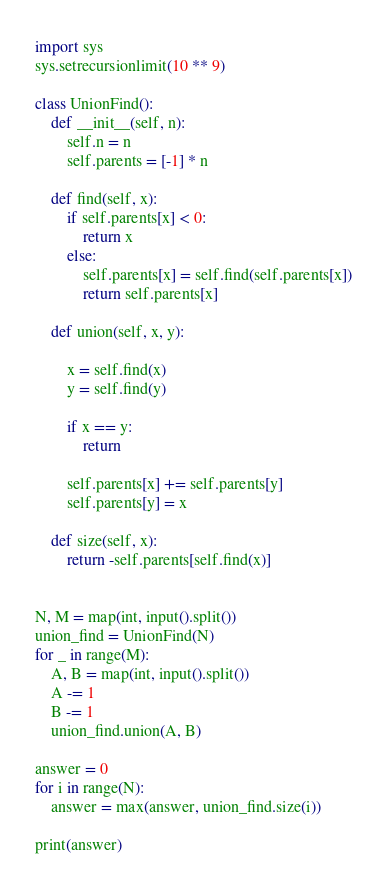Convert code to text. <code><loc_0><loc_0><loc_500><loc_500><_Python_>import sys
sys.setrecursionlimit(10 ** 9)

class UnionFind():
    def __init__(self, n):
        self.n = n
        self.parents = [-1] * n

    def find(self, x):
        if self.parents[x] < 0:
            return x
        else:
            self.parents[x] = self.find(self.parents[x])
            return self.parents[x]

    def union(self, x, y):

        x = self.find(x)
        y = self.find(y)

        if x == y:
            return

        self.parents[x] += self.parents[y]
        self.parents[y] = x

    def size(self, x):
        return -self.parents[self.find(x)]


N, M = map(int, input().split()) 
union_find = UnionFind(N)
for _ in range(M):
    A, B = map(int, input().split())
    A -= 1
    B -= 1
    union_find.union(A, B)

answer = 0
for i in range(N):
    answer = max(answer, union_find.size(i))

print(answer)
</code> 